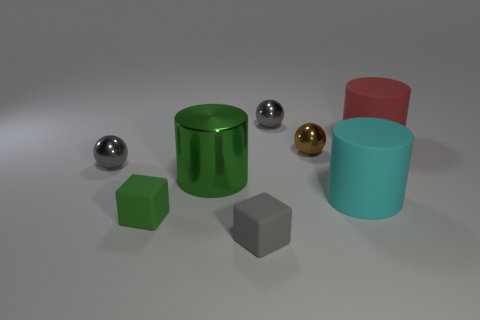Subtract all metallic cylinders. How many cylinders are left? 2 Subtract all brown cubes. How many gray balls are left? 2 Subtract 1 spheres. How many spheres are left? 2 Add 1 gray shiny balls. How many objects exist? 9 Subtract all blue cylinders. Subtract all cyan balls. How many cylinders are left? 3 Add 3 large cyan rubber cylinders. How many large cyan rubber cylinders exist? 4 Subtract 0 yellow balls. How many objects are left? 8 Subtract all cubes. How many objects are left? 6 Subtract all brown shiny things. Subtract all large brown objects. How many objects are left? 7 Add 4 gray shiny spheres. How many gray shiny spheres are left? 6 